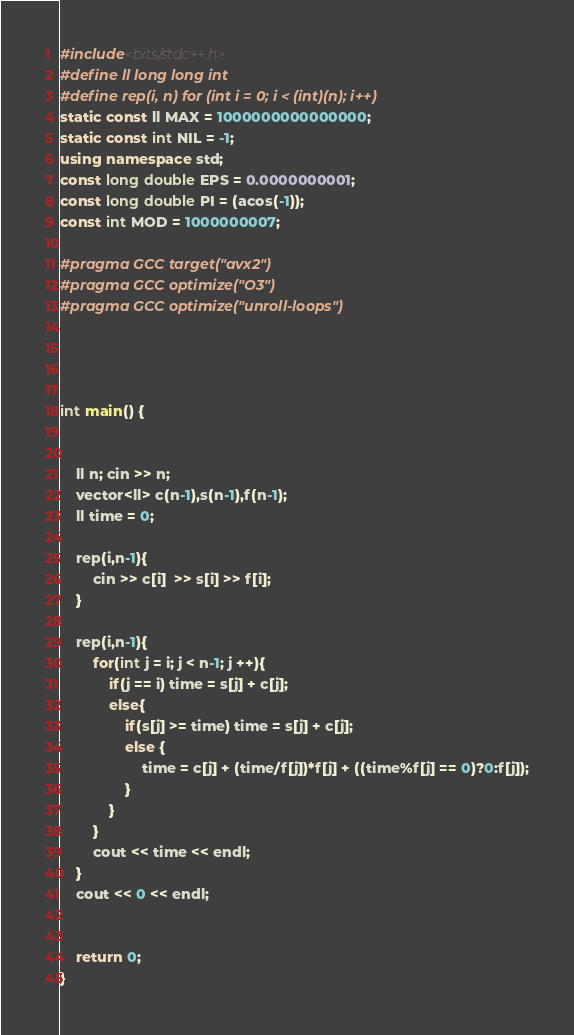Convert code to text. <code><loc_0><loc_0><loc_500><loc_500><_C++_>#include<bits/stdc++.h>
#define ll long long int
#define rep(i, n) for (int i = 0; i < (int)(n); i++)
static const ll MAX = 1000000000000000;
static const int NIL = -1;
using namespace std;
const long double EPS = 0.0000000001;
const long double PI = (acos(-1));
const int MOD = 1000000007;

#pragma GCC target("avx2")
#pragma GCC optimize("O3")
#pragma GCC optimize("unroll-loops")




int main() {


    ll n; cin >> n;
    vector<ll> c(n-1),s(n-1),f(n-1);
    ll time = 0;

    rep(i,n-1){
        cin >> c[i]  >> s[i] >> f[i];
    }

    rep(i,n-1){
        for(int j = i; j < n-1; j ++){
            if(j == i) time = s[j] + c[j];
            else{
                if(s[j] >= time) time = s[j] + c[j];
                else {
                    time = c[j] + (time/f[j])*f[j] + ((time%f[j] == 0)?0:f[j]);
                }
            }
        }
        cout << time << endl;
    }
    cout << 0 << endl;


    return 0;
}
</code> 